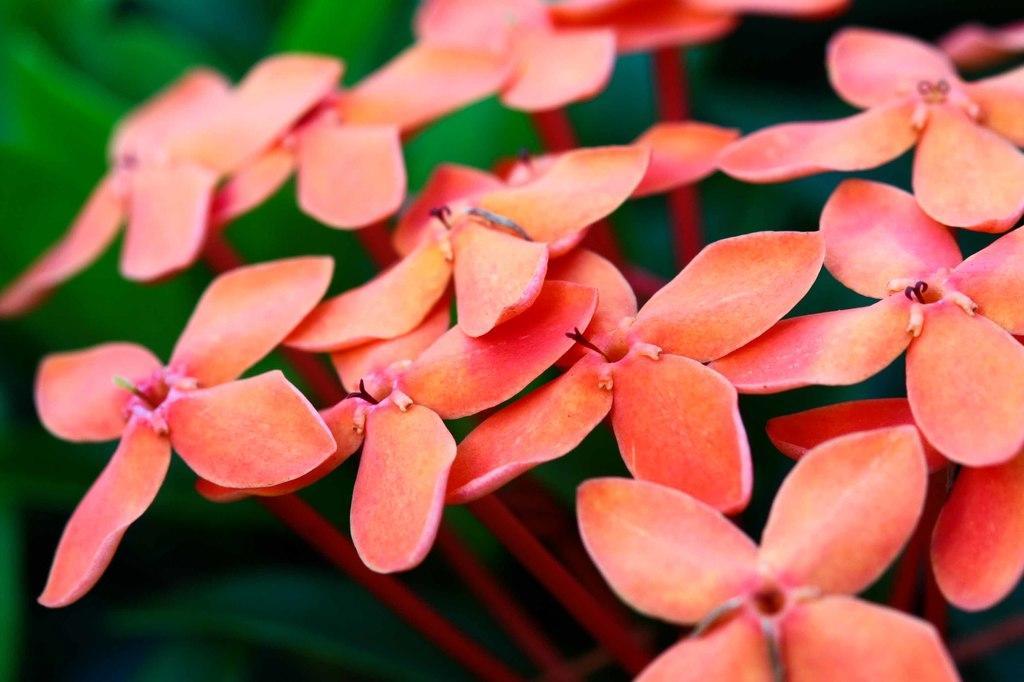In one or two sentences, can you explain what this image depicts? In this image we can see flowers which are in peach color. 